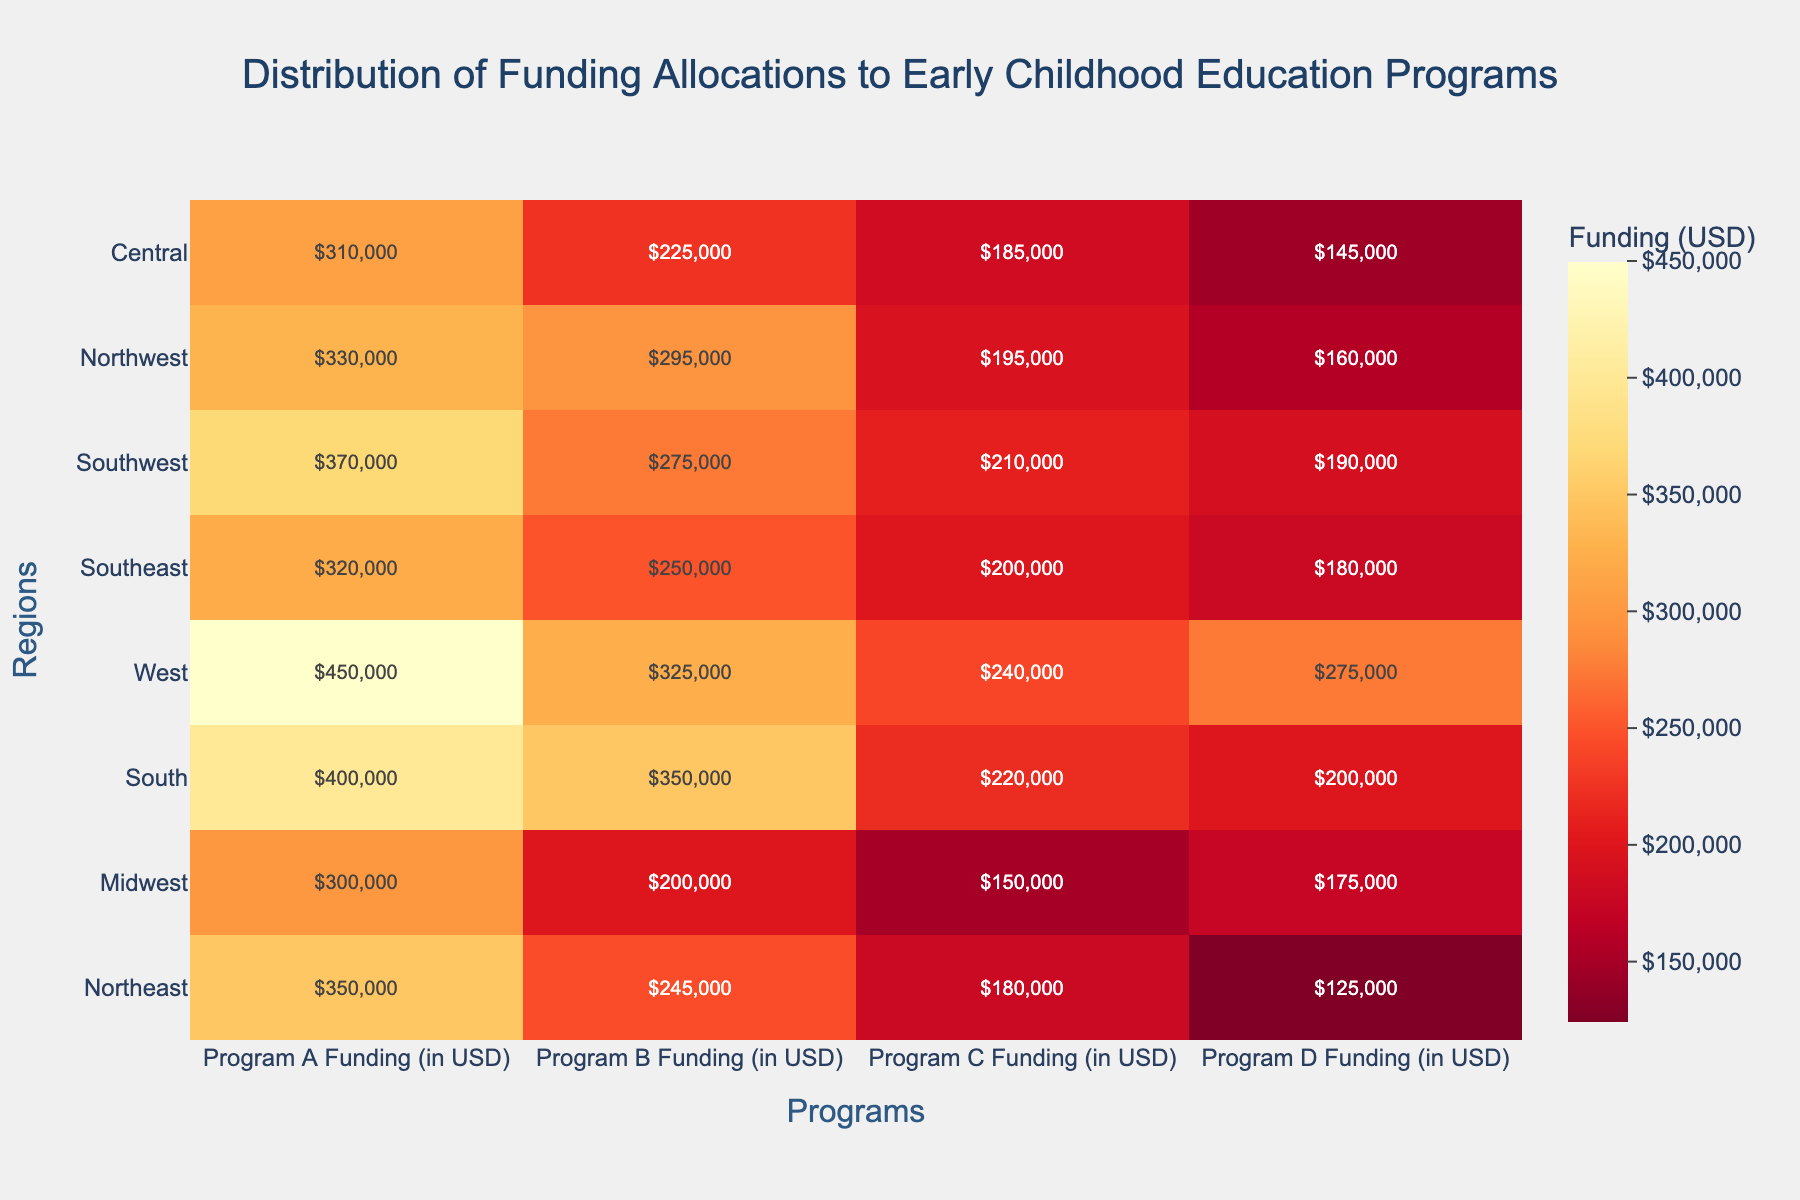Which region receives the highest funding for Program D? To determine this, look for the highest value in the "Program D Funding" column. The West region has the highest funding for Program D at $275,000.
Answer: West What is the total funding allocated to the Northeast region across all programs? Sum the funding allocations for Program A, B, C, and D in the Northeast region: $350,000 + $245,000 + $180,000 + $125,000 = $900,000.
Answer: $900,000 Which program has the lowest funding allocation in the Midwest region? Compare the funding amounts for all programs in the Midwest region. Program C has the lowest funding at $150,000.
Answer: Program C How does the funding for Program B in the Southeast compare to the Southwest? Compare the values for Program B in both regions: $250,000 in the Southeast and $275,000 in the Southwest. The Southwest has $25,000 more than the Southeast.
Answer: Southwest, $25,000 more What is the average funding for Program A across all regions? Sum all the funding amounts for Program A across the regions and divide by the number of regions (8): ($350,000 + $300,000 + $400,000 + $450,000 + $320,000 + $370,000 + $330,000 + $310,000) / 8 = $3,230,000 / 8 = $403,750.
Answer: $403,750 In which region is the disparity between the highest and lowest funded program the greatest? Calculate the disparity (highest - lowest) for each region:
- Northeast: $350,000 - $125,000 = $225,000
- Midwest: $300,000 - $150,000 = $150,000
- South: $400,000 - $200,000 = $200,000
- West: $450,000 - $240,000 = $210,000
- Southeast: $320,000 - $180,000 = $140,000
- Southwest: $370,000 - $190,000 = $180,000
- Northwest: $330,000 - $160,000 = $170,000
- Central: $310,000 - $145,000 = $165,000
The Northeast has the greatest disparity of $225,000.
Answer: Northeast Which program has the most evenly distributed funding across all regions? Look for the program with the least variation in funding across regions. Program A has values closely clustered compared to other programs, indicating more even distribution.
Answer: Program A What is the median funding for Program C across all regions? List all funding values for Program C and find the median: $180,000, $150,000, $220,000, $240,000, $200,000, $210,000, $195,000, $185,000. Arrange in order: $150,000, $180,000, $185,000, $195,000, $200,000, $210,000, $220,000, $240,000. Median is the average of the 4th and 5th values: ($195,000 + $200,000) / 2 = $197,500.
Answer: $197,500 If we double the funding for Program B in the Northwest, how much would it be? Double the current funding for Program B in the Northwest: $295,000 * 2 = $590,000.
Answer: $590,000 